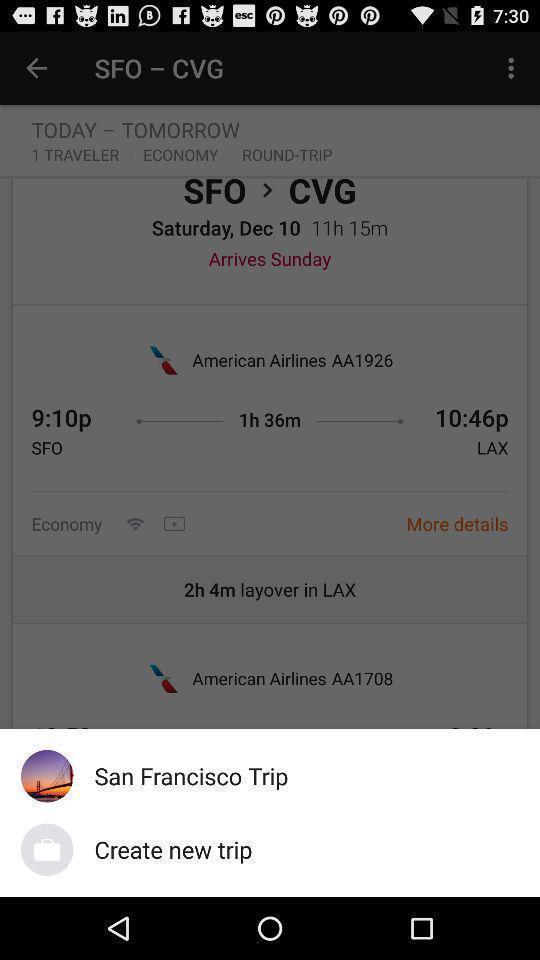Explain what's happening in this screen capture. Pop-up widget displaying saved trip. 